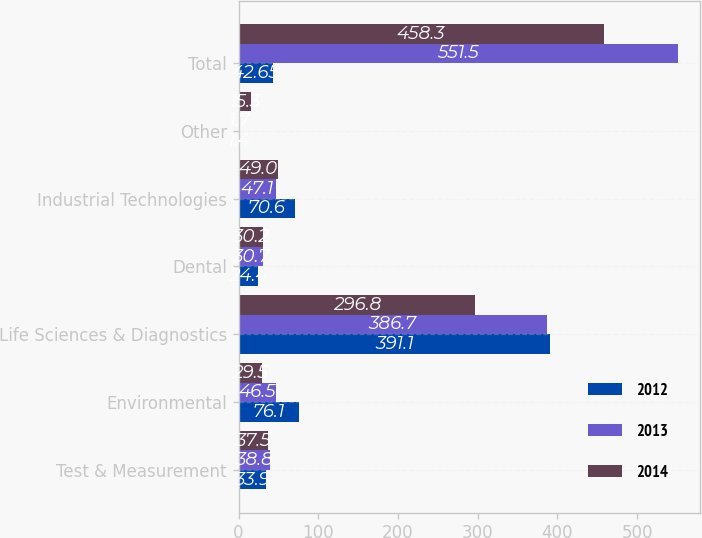Convert chart. <chart><loc_0><loc_0><loc_500><loc_500><stacked_bar_chart><ecel><fcel>Test & Measurement<fcel>Environmental<fcel>Life Sciences & Diagnostics<fcel>Dental<fcel>Industrial Technologies<fcel>Other<fcel>Total<nl><fcel>2012<fcel>33.9<fcel>76.1<fcel>391.1<fcel>24.4<fcel>70.6<fcel>1.4<fcel>42.65<nl><fcel>2013<fcel>38.8<fcel>46.5<fcel>386.7<fcel>30.7<fcel>47.1<fcel>1.7<fcel>551.5<nl><fcel>2014<fcel>37.5<fcel>29.5<fcel>296.8<fcel>30.2<fcel>49<fcel>15.3<fcel>458.3<nl></chart> 